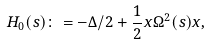<formula> <loc_0><loc_0><loc_500><loc_500>H _ { 0 } ( s ) \colon = - \Delta / 2 + \frac { 1 } { 2 } x \Omega ^ { 2 } ( s ) x ,</formula> 